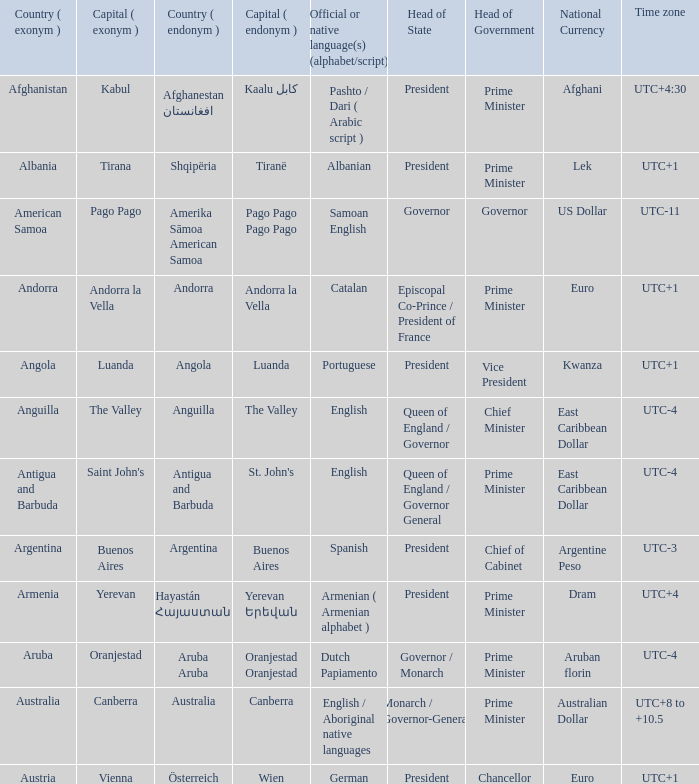How many capital cities does Australia have? 1.0. 